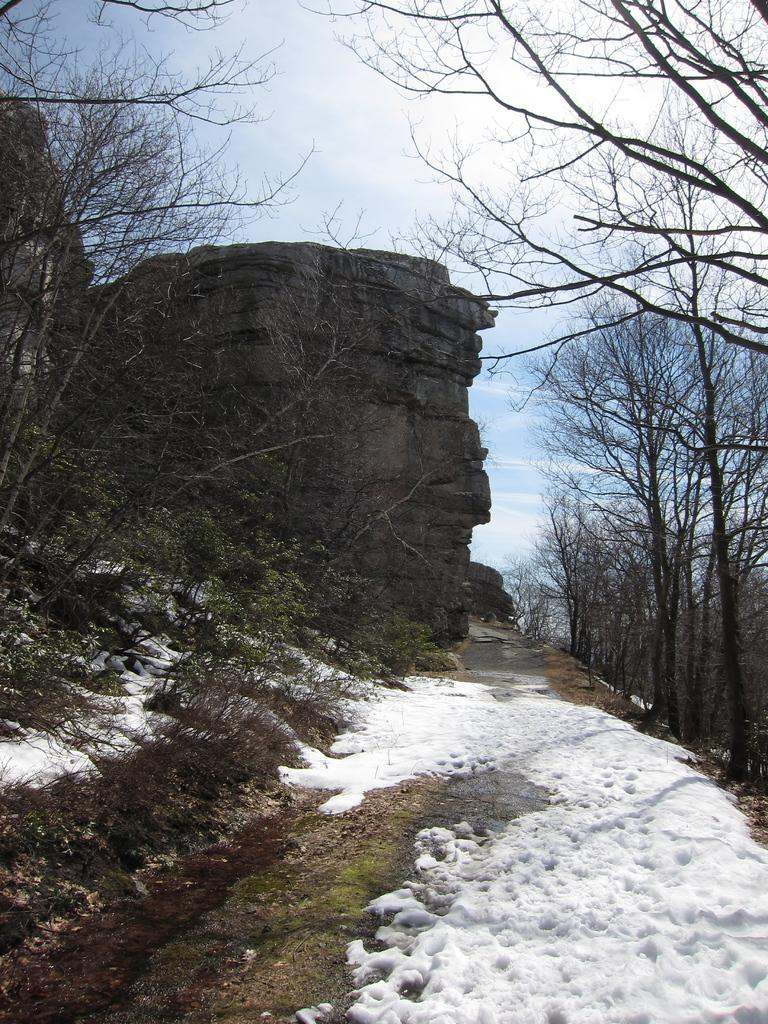What type of weather is depicted in the image? The image shows snow, which indicates cold weather. What type of vegetation can be seen in the image? There is grass and plants visible in the image. What type of trees are present in the image? There are bare trees in the image. What is the ground made of in the image? There is a rock in the image. What is visible in the background of the image? The sky is visible in the background of the image, with clouds present. Where is the lamp placed in the image? There is no lamp present in the image. What type of bag can be seen hanging from the tree in the image? There is no bag hanging from the tree in the image. 